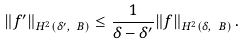<formula> <loc_0><loc_0><loc_500><loc_500>\| f ^ { \prime } \| _ { H ^ { 2 } ( \delta ^ { \prime } , \ B ) } \leq \frac { 1 } { \delta - \delta ^ { \prime } } \| f \| _ { H ^ { 2 } ( \delta , \ B ) } \, .</formula> 